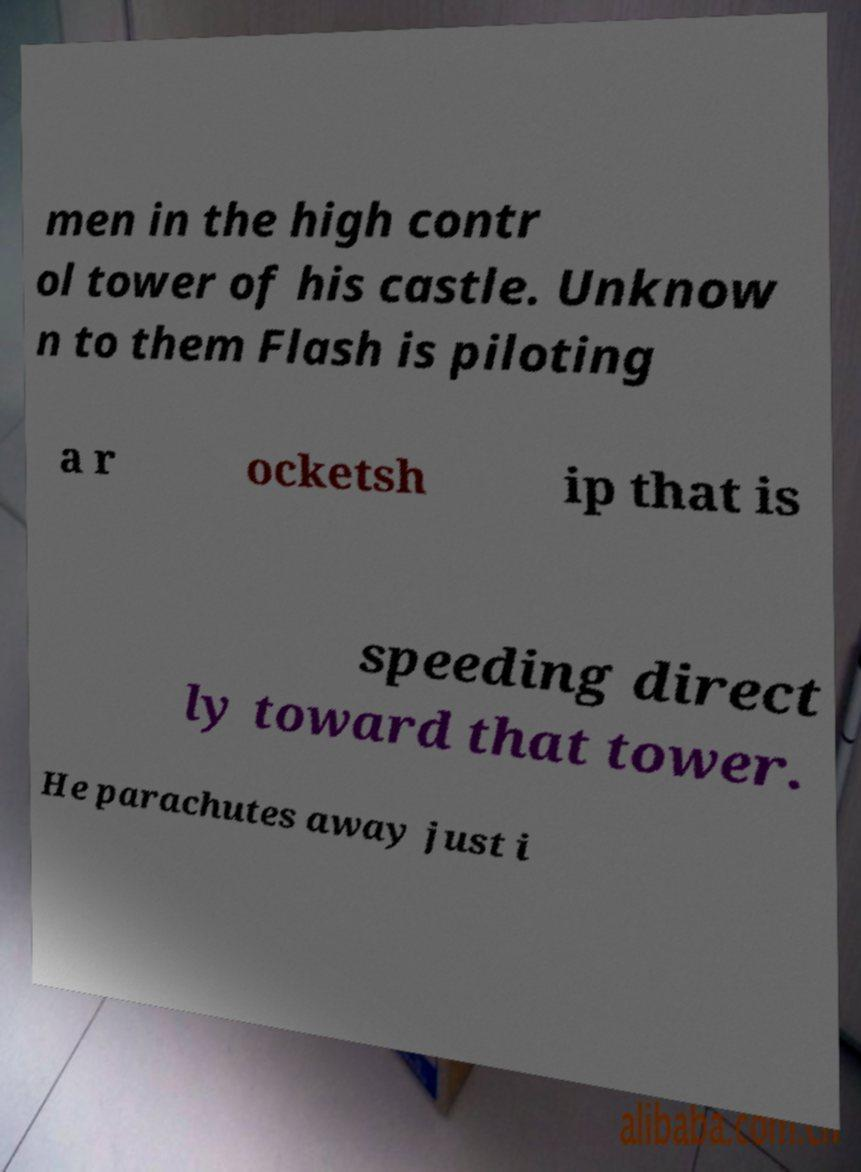Could you assist in decoding the text presented in this image and type it out clearly? men in the high contr ol tower of his castle. Unknow n to them Flash is piloting a r ocketsh ip that is speeding direct ly toward that tower. He parachutes away just i 